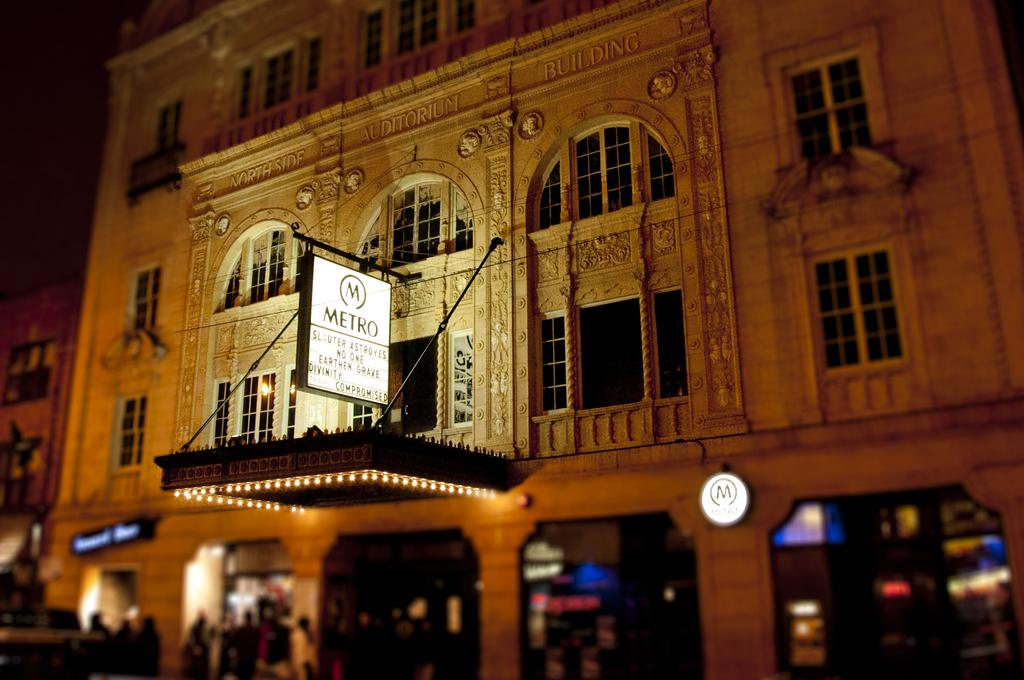What color is the building in the image? The building in the image is yellow. Where is the building located in relation to other elements in the image? The building is in the front. What can be found on the front bottom side of the image? There are shops and a naming board on the front bottom side of the image. What is written on the naming board? The word "Metro" is written on the naming board. What type of wheel is visible on the minister's vehicle in the image? There is no minister or vehicle present in the image, so no wheel can be observed. 